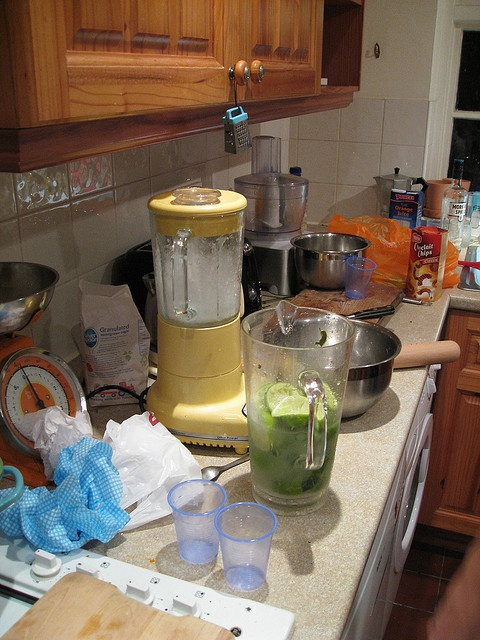Describe the objects in this image and their specific colors. I can see cup in black, darkgray, and gray tones, bowl in black and gray tones, cup in black, darkgray, lightgray, and gray tones, bowl in black, gray, and maroon tones, and bowl in black and gray tones in this image. 